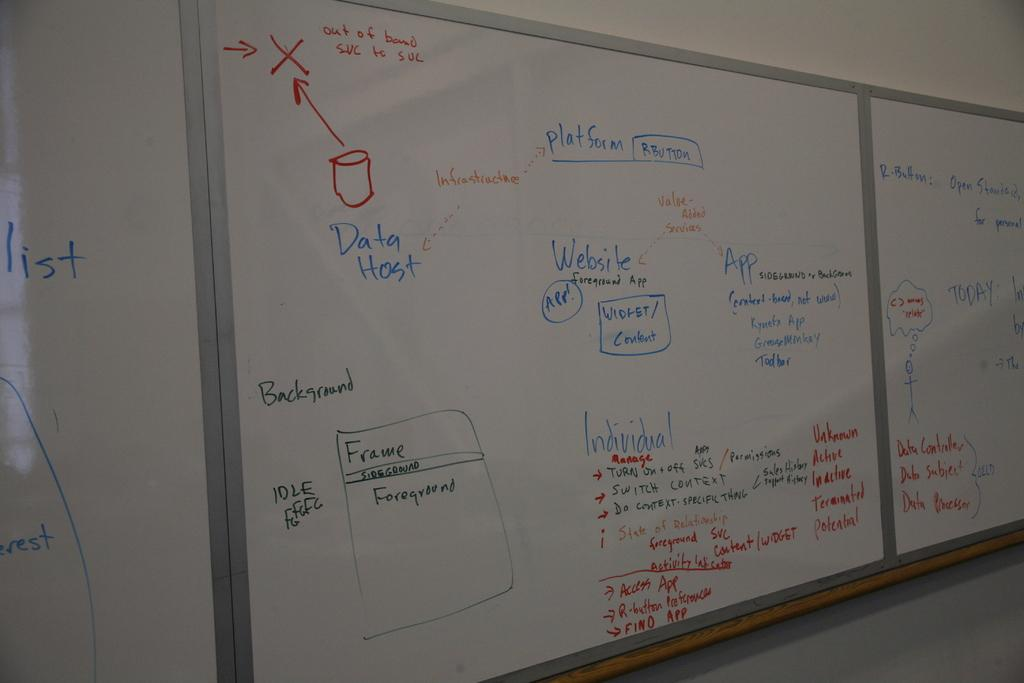Provide a one-sentence caption for the provided image. a white board with the word data host on it. 